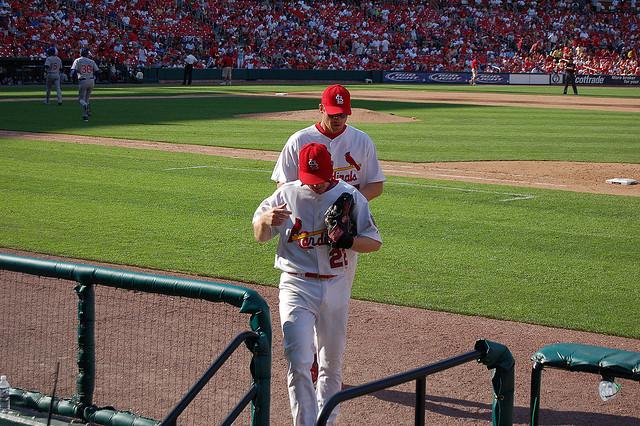Are there any fans at the game?
Be succinct. Yes. What team are the players on?
Quick response, please. Cardinals. Where are the players going?
Short answer required. Dugout. 